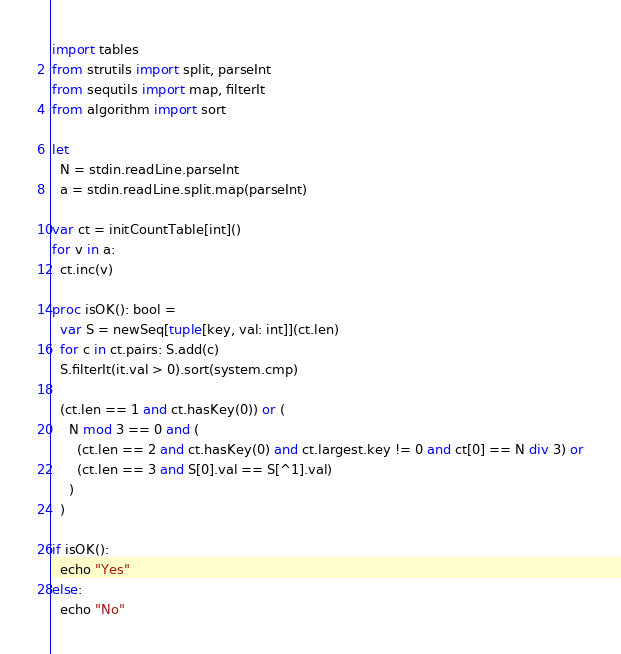<code> <loc_0><loc_0><loc_500><loc_500><_Nim_>import tables
from strutils import split, parseInt
from sequtils import map, filterIt
from algorithm import sort

let
  N = stdin.readLine.parseInt
  a = stdin.readLine.split.map(parseInt)

var ct = initCountTable[int]()
for v in a:
  ct.inc(v)

proc isOK(): bool =
  var S = newSeq[tuple[key, val: int]](ct.len)
  for c in ct.pairs: S.add(c)
  S.filterIt(it.val > 0).sort(system.cmp)

  (ct.len == 1 and ct.hasKey(0)) or (
    N mod 3 == 0 and (
      (ct.len == 2 and ct.hasKey(0) and ct.largest.key != 0 and ct[0] == N div 3) or
      (ct.len == 3 and S[0].val == S[^1].val)
    )
  )

if isOK():
  echo "Yes"
else:
  echo "No"
</code> 